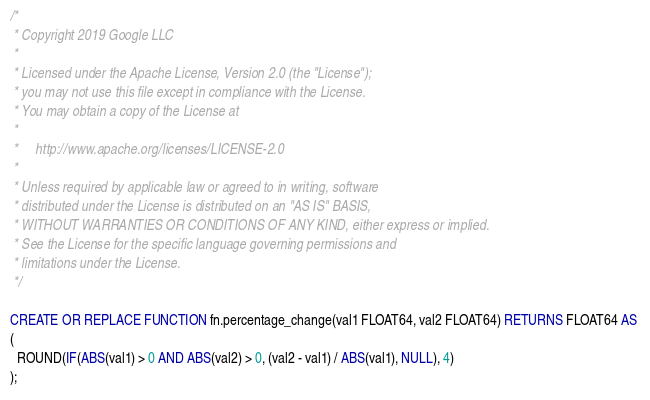Convert code to text. <code><loc_0><loc_0><loc_500><loc_500><_SQL_>/*
 * Copyright 2019 Google LLC
 *
 * Licensed under the Apache License, Version 2.0 (the "License");
 * you may not use this file except in compliance with the License.
 * You may obtain a copy of the License at
 *
 *     http://www.apache.org/licenses/LICENSE-2.0
 *
 * Unless required by applicable law or agreed to in writing, software
 * distributed under the License is distributed on an "AS IS" BASIS,
 * WITHOUT WARRANTIES OR CONDITIONS OF ANY KIND, either express or implied.
 * See the License for the specific language governing permissions and
 * limitations under the License.
 */

CREATE OR REPLACE FUNCTION fn.percentage_change(val1 FLOAT64, val2 FLOAT64) RETURNS FLOAT64 AS 
(
  ROUND(IF(ABS(val1) > 0 AND ABS(val2) > 0, (val2 - val1) / ABS(val1), NULL), 4)
);
</code> 